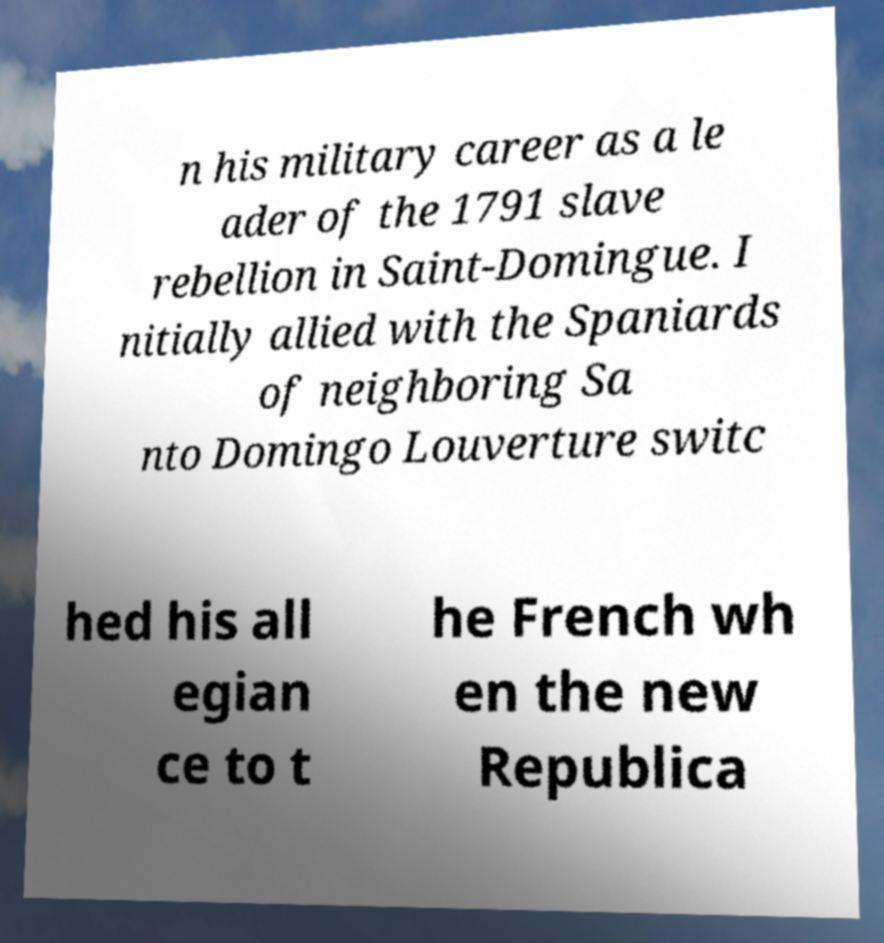I need the written content from this picture converted into text. Can you do that? n his military career as a le ader of the 1791 slave rebellion in Saint-Domingue. I nitially allied with the Spaniards of neighboring Sa nto Domingo Louverture switc hed his all egian ce to t he French wh en the new Republica 